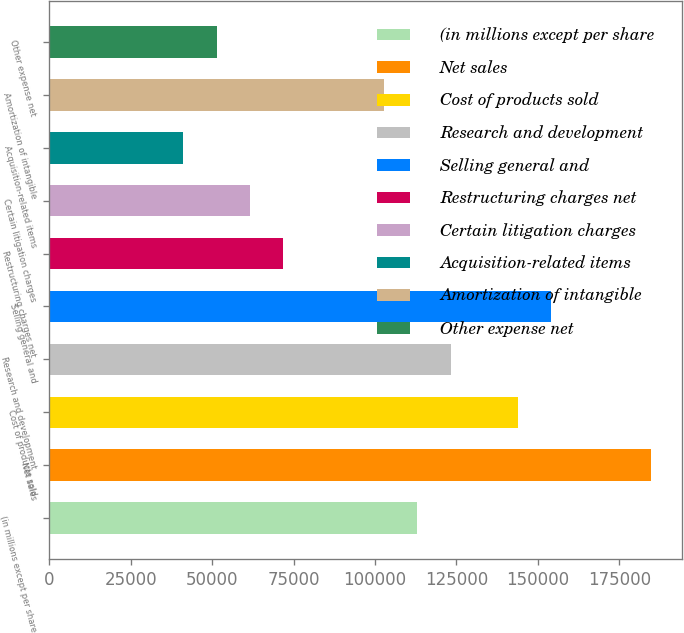Convert chart. <chart><loc_0><loc_0><loc_500><loc_500><bar_chart><fcel>(in millions except per share<fcel>Net sales<fcel>Cost of products sold<fcel>Research and development<fcel>Selling general and<fcel>Restructuring charges net<fcel>Certain litigation charges<fcel>Acquisition-related items<fcel>Amortization of intangible<fcel>Other expense net<nl><fcel>112957<fcel>184837<fcel>143763<fcel>123225<fcel>154031<fcel>71882.1<fcel>61613.5<fcel>41076.2<fcel>102688<fcel>51344.9<nl></chart> 